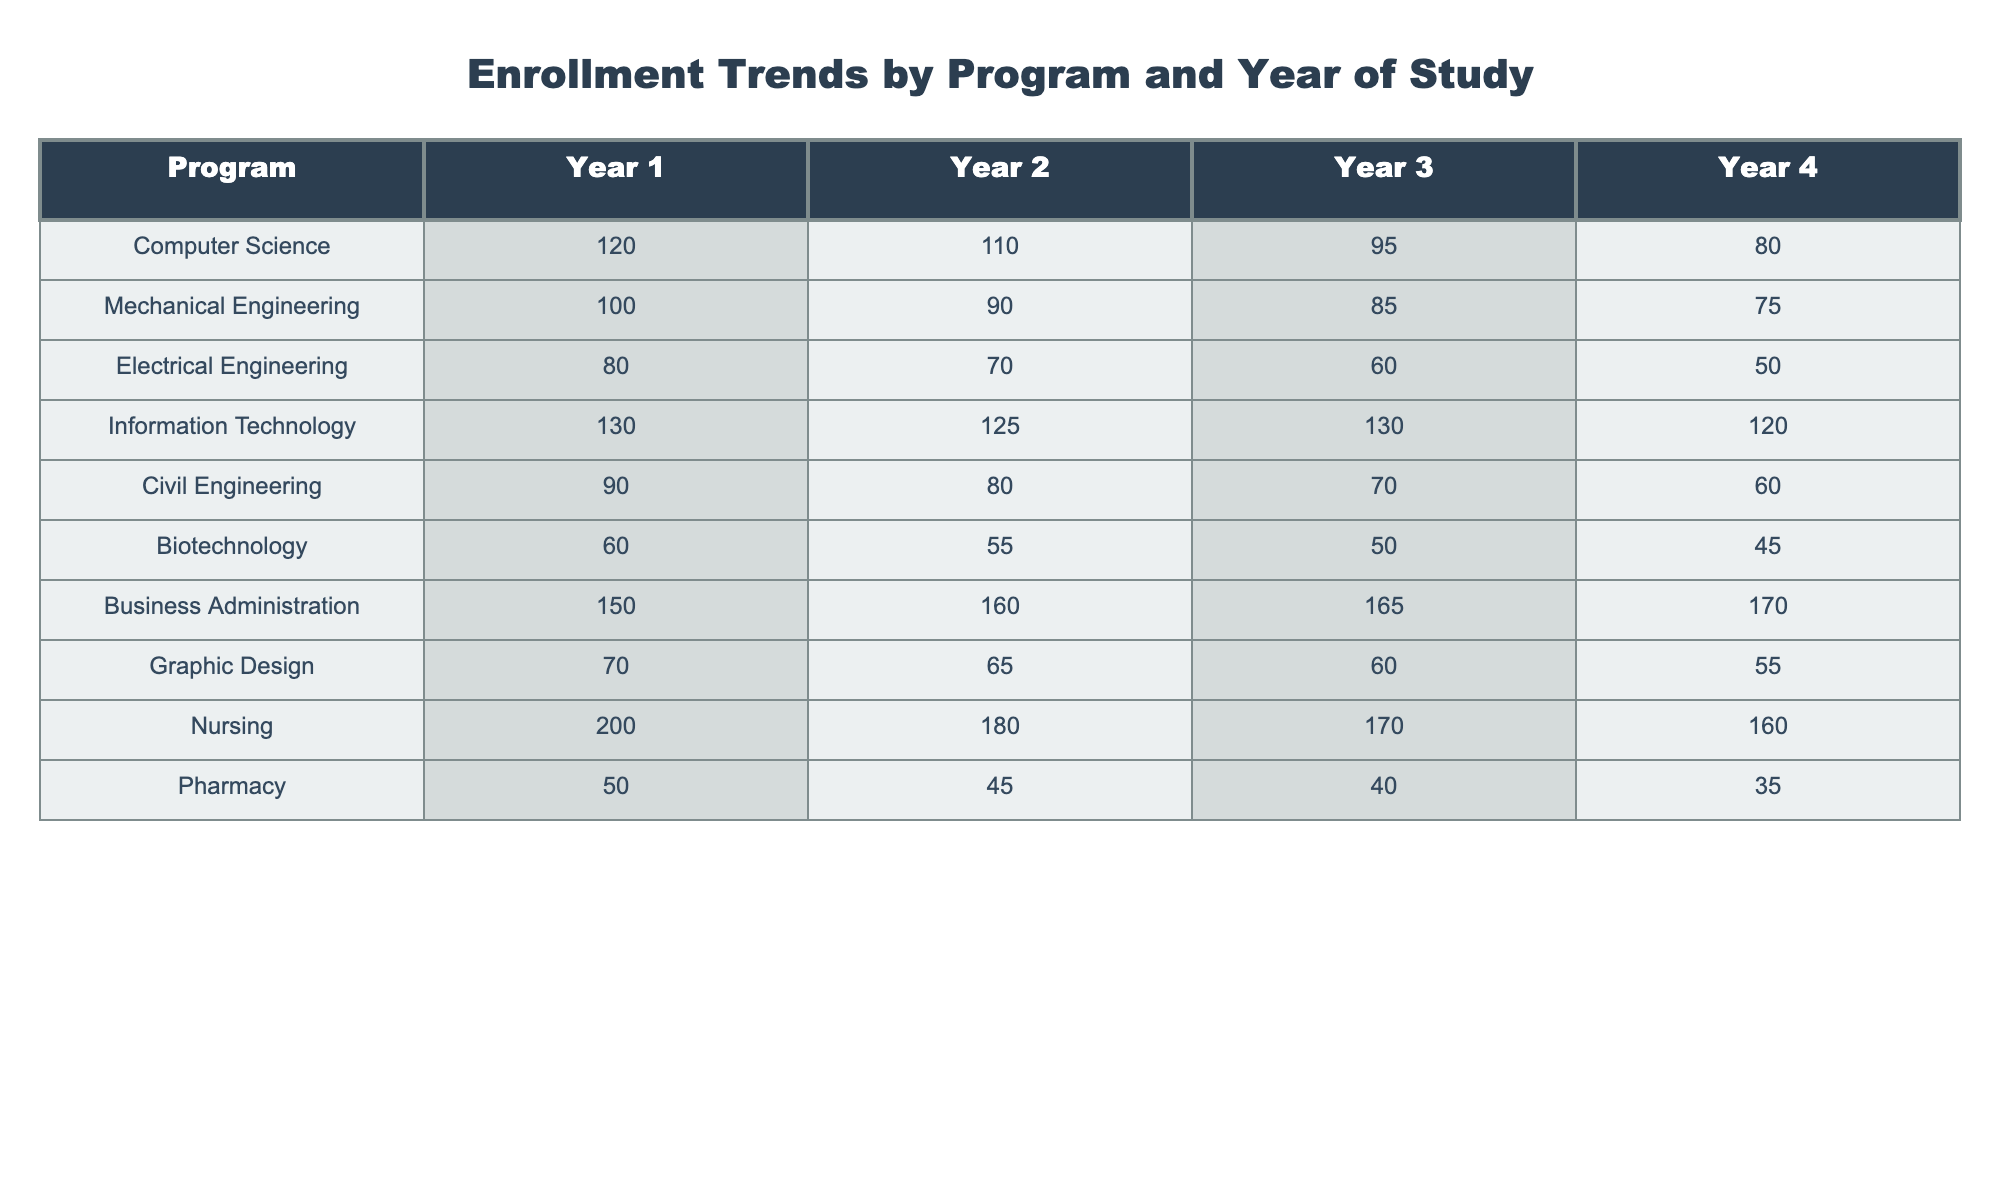What is the enrollment number for Nursing in Year 3? The table lists the enrollment numbers by program and year. Looking at the Nursing row under Year 3, the value is 170.
Answer: 170 Which program had the highest enrollment in Year 1? By comparing the enrollment numbers across all programs in Year 1, Business Administration has the highest enrollment at 150.
Answer: Business Administration What is the total enrollment for Information Technology over all four years? The total enrollment for Information Technology can be calculated by summing the values for each year: 130 + 125 + 130 + 120 = 505.
Answer: 505 Did Electrical Engineering have more students enrolled in Year 2 compared to Year 3? In Year 2, Electrical Engineering had 70 students, and in Year 3, it had 60. Since 70 is greater than 60, the statement is true.
Answer: Yes Which program has the lowest total enrollment across all years? To find the lowest total enrollment, sum each program's enrollment: Biotechnology (60 + 55 + 50 + 45 = 210) and Pharmacy (50 + 45 + 40 + 35 = 170). Comparing these sums, Pharmacy has the lowest total enrollment of 170.
Answer: Pharmacy What is the average enrollment for Computer Science over its four years? To find the average enrollment, sum the four years: 120 + 110 + 95 + 80 = 405, and then divide by 4: 405 / 4 = 101.25.
Answer: 101.25 Is the enrollment trend for Civil Engineering decreasing across the years? We can check the enrollment numbers for Civil Engineering: Year 1 has 90, Year 2 has 80, Year 3 has 70, and Year 4 has 60. Since the numbers consistently decrease from Year 1 to Year 4, the trend is indeed decreasing.
Answer: Yes How many students are enrolled in Year 4 for all engineering programs combined? The engineering programs include Mechanical, Electrical, Civil, and Computer Science. Adding the Year 4 enrollments gives: 75 (Mechanical) + 50 (Electrical) + 60 (Civil) + 80 (Computer Science) = 265 students in total.
Answer: 265 Which year had the highest enrollment for Business Administration? From the table, we can see the enrollments for Business Administration are: 150 (Year 1), 160 (Year 2), 165 (Year 3), and 170 (Year 4). The highest enrollment occurs in Year 4 with 170 students.
Answer: Year 4 